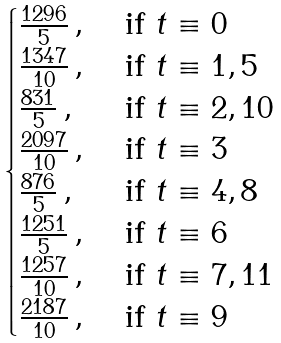<formula> <loc_0><loc_0><loc_500><loc_500>\begin{cases} \frac { 1 2 9 6 } { 5 } \, , & \text { if } t \equiv 0 \\ \frac { 1 3 4 7 } { 1 0 } \, , & \text { if } t \equiv 1 , 5 \\ \frac { 8 3 1 } { 5 } \, , & \text { if } t \equiv 2 , 1 0 \\ \frac { 2 0 9 7 } { 1 0 } \, , & \text { if } t \equiv 3 \\ \frac { 8 7 6 } { 5 } \, , & \text { if } t \equiv 4 , 8 \\ \frac { 1 2 5 1 } { 5 } \, , & \text { if } t \equiv 6 \\ \frac { 1 2 5 7 } { 1 0 } \, , & \text { if } t \equiv 7 , 1 1 \\ \frac { 2 1 8 7 } { 1 0 } \, , & \text { if } t \equiv 9 \\ \end{cases}</formula> 